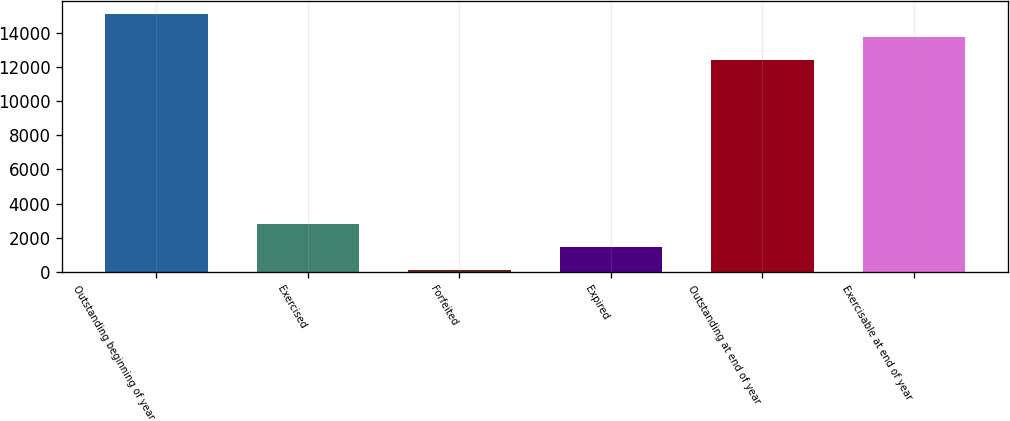Convert chart to OTSL. <chart><loc_0><loc_0><loc_500><loc_500><bar_chart><fcel>Outstanding beginning of year<fcel>Exercised<fcel>Forfeited<fcel>Expired<fcel>Outstanding at end of year<fcel>Exercisable at end of year<nl><fcel>15071.4<fcel>2786.4<fcel>89<fcel>1437.7<fcel>12374<fcel>13722.7<nl></chart> 